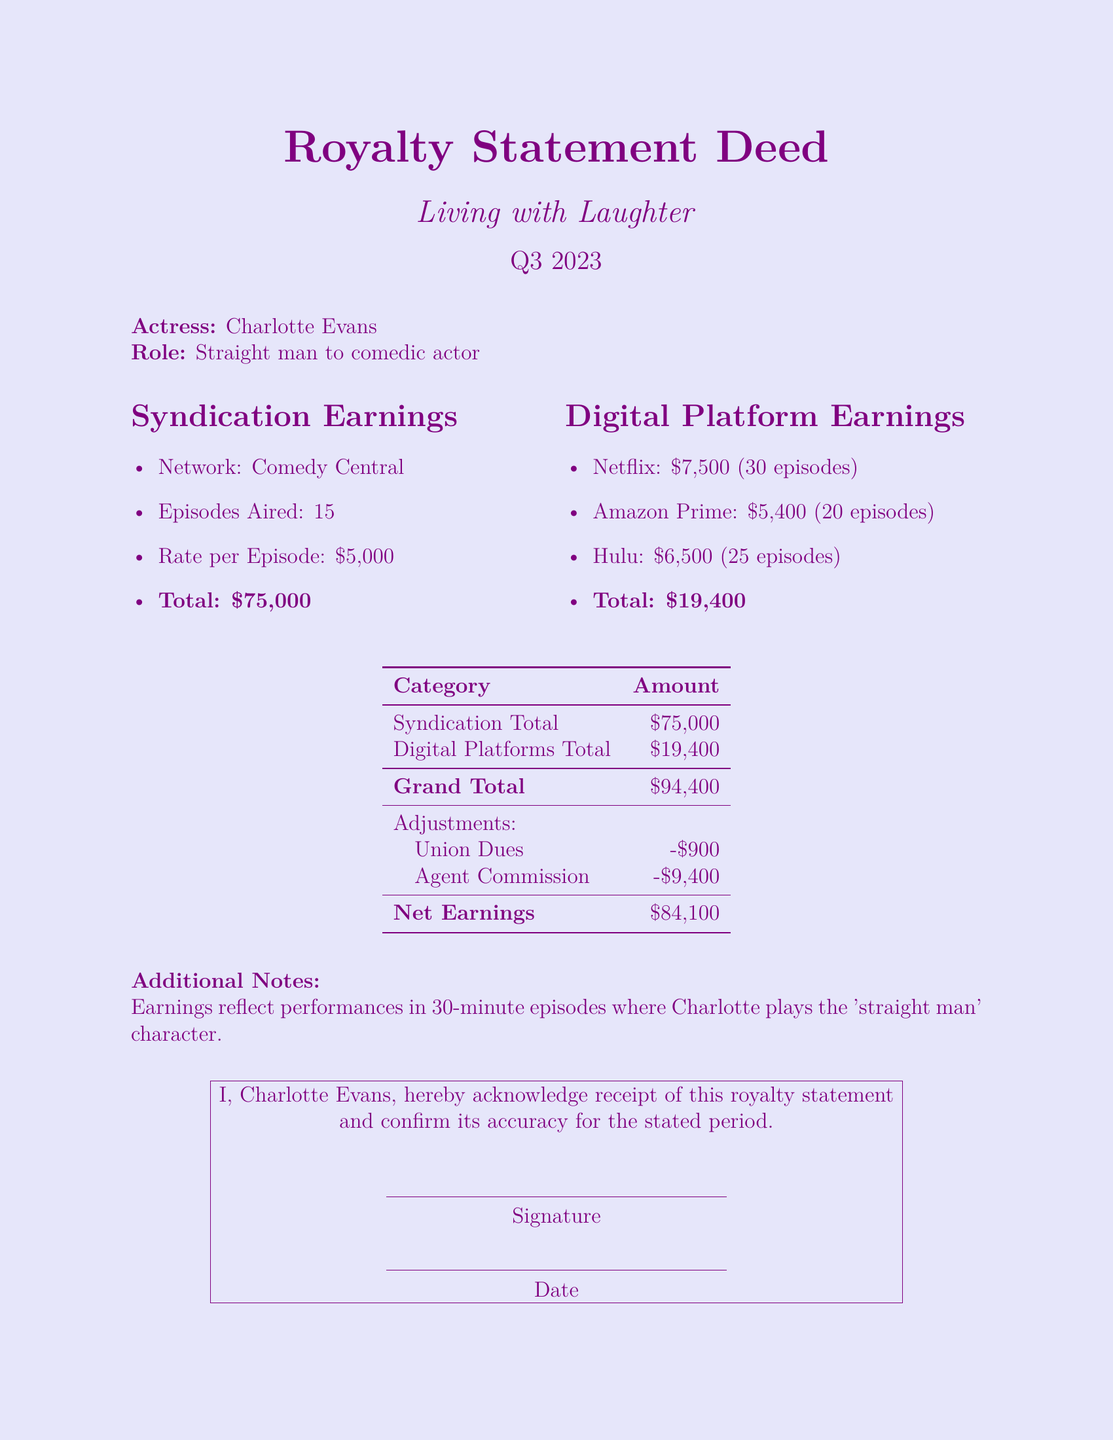What is the total syndication earnings? The total syndication earnings are explicitly stated in the document as $75,000.
Answer: $75,000 How much did Charlotte earn from Hulu? The document specifies the earnings from Hulu as $6,500.
Answer: $6,500 What is the grand total of all earnings before deductions? The grand total before any adjustments is provided as $94,400.
Answer: $94,400 What are the adjustments mentioned in the document? The adjustments include Union Dues of -$900 and Agent Commission of -$9,400.
Answer: Union Dues, Agent Commission What is the net earnings after adjustments? The net earnings after the specified adjustments totals to $84,100.
Answer: $84,100 Who is the actress mentioned in the document? The document clearly states that the actress is Charlotte Evans.
Answer: Charlotte Evans How many episodes were aired on Comedy Central? The document indicates that 15 episodes aired on Comedy Central.
Answer: 15 What role does Charlotte Evans play in the show? The document states that she plays the straight man to the comedic actor.
Answer: Straight man to comedic actor On which digital platform did Charlotte earn the least? The earnings from Amazon Prime, which amount to $5,400, are the lowest among the platforms listed.
Answer: Amazon Prime 